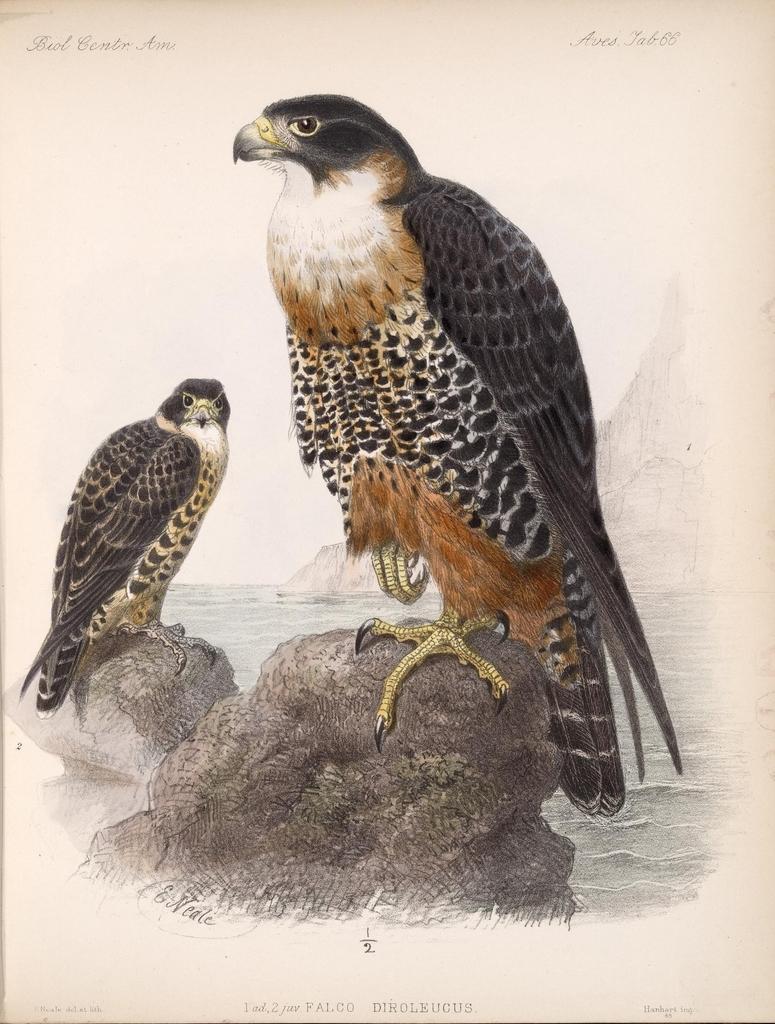Could you give a brief overview of what you see in this image? In this image we can see a poster, there are two birds on the stones, also we can see some text, water and mountains. 